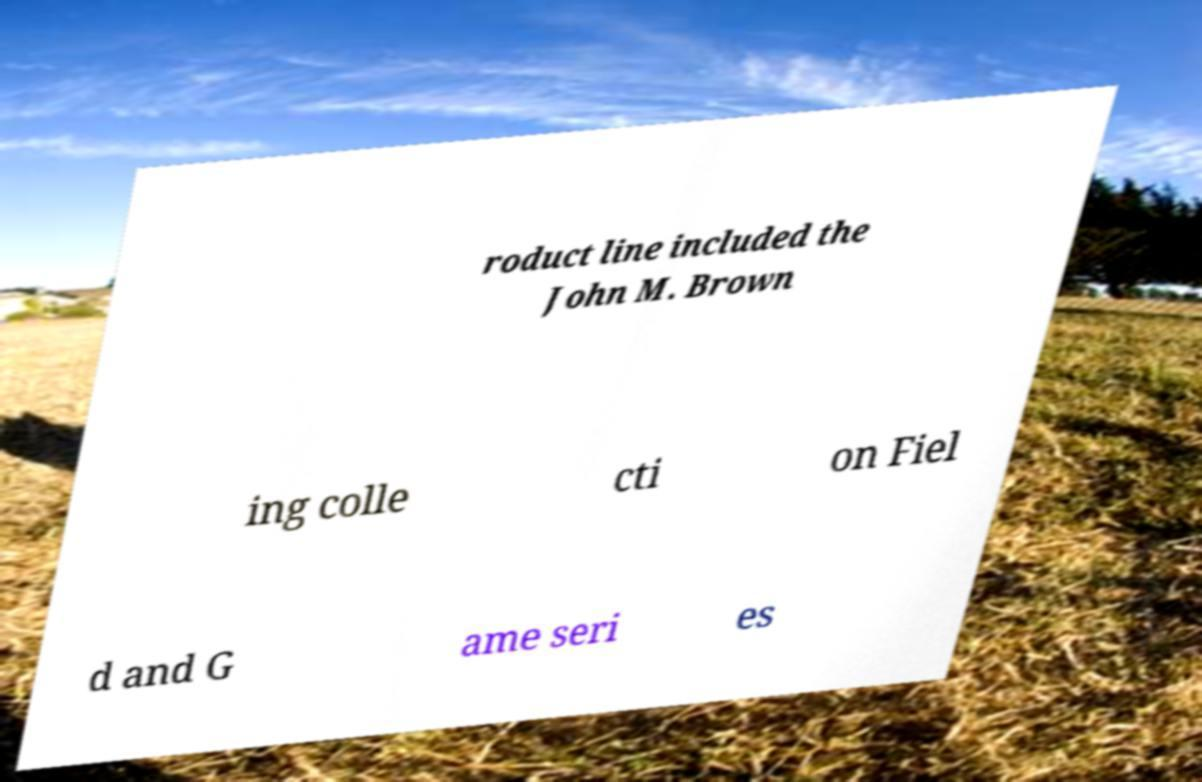Please identify and transcribe the text found in this image. roduct line included the John M. Brown ing colle cti on Fiel d and G ame seri es 